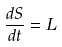<formula> <loc_0><loc_0><loc_500><loc_500>\frac { d S } { d t } = L</formula> 